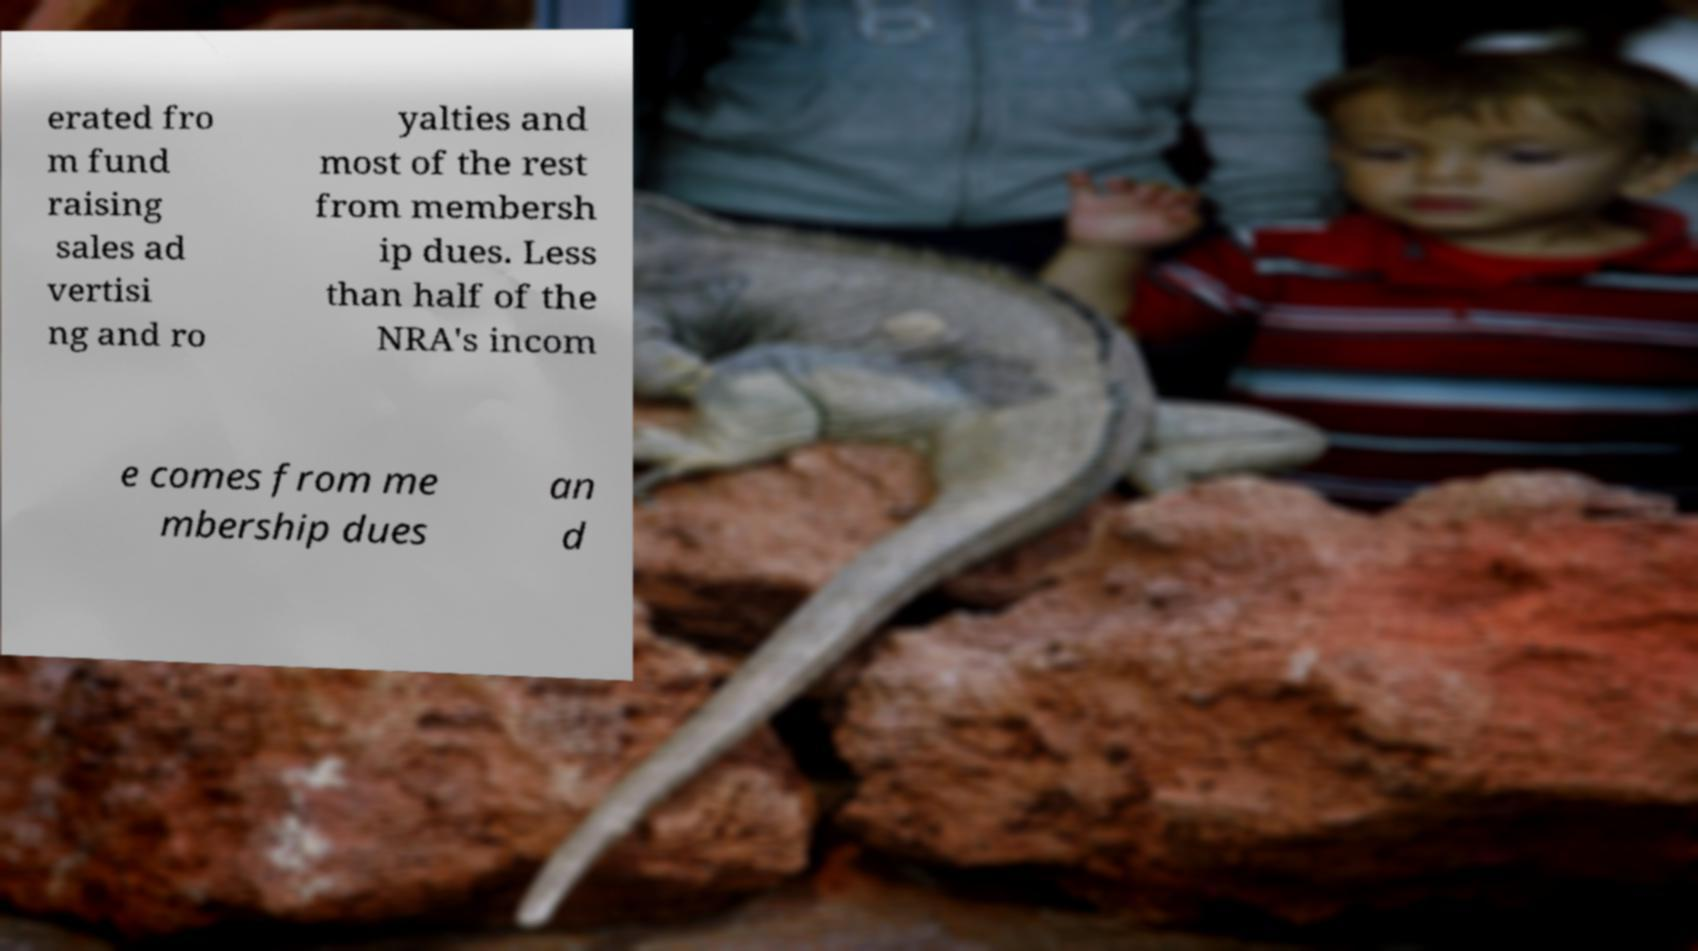Can you accurately transcribe the text from the provided image for me? erated fro m fund raising sales ad vertisi ng and ro yalties and most of the rest from membersh ip dues. Less than half of the NRA's incom e comes from me mbership dues an d 